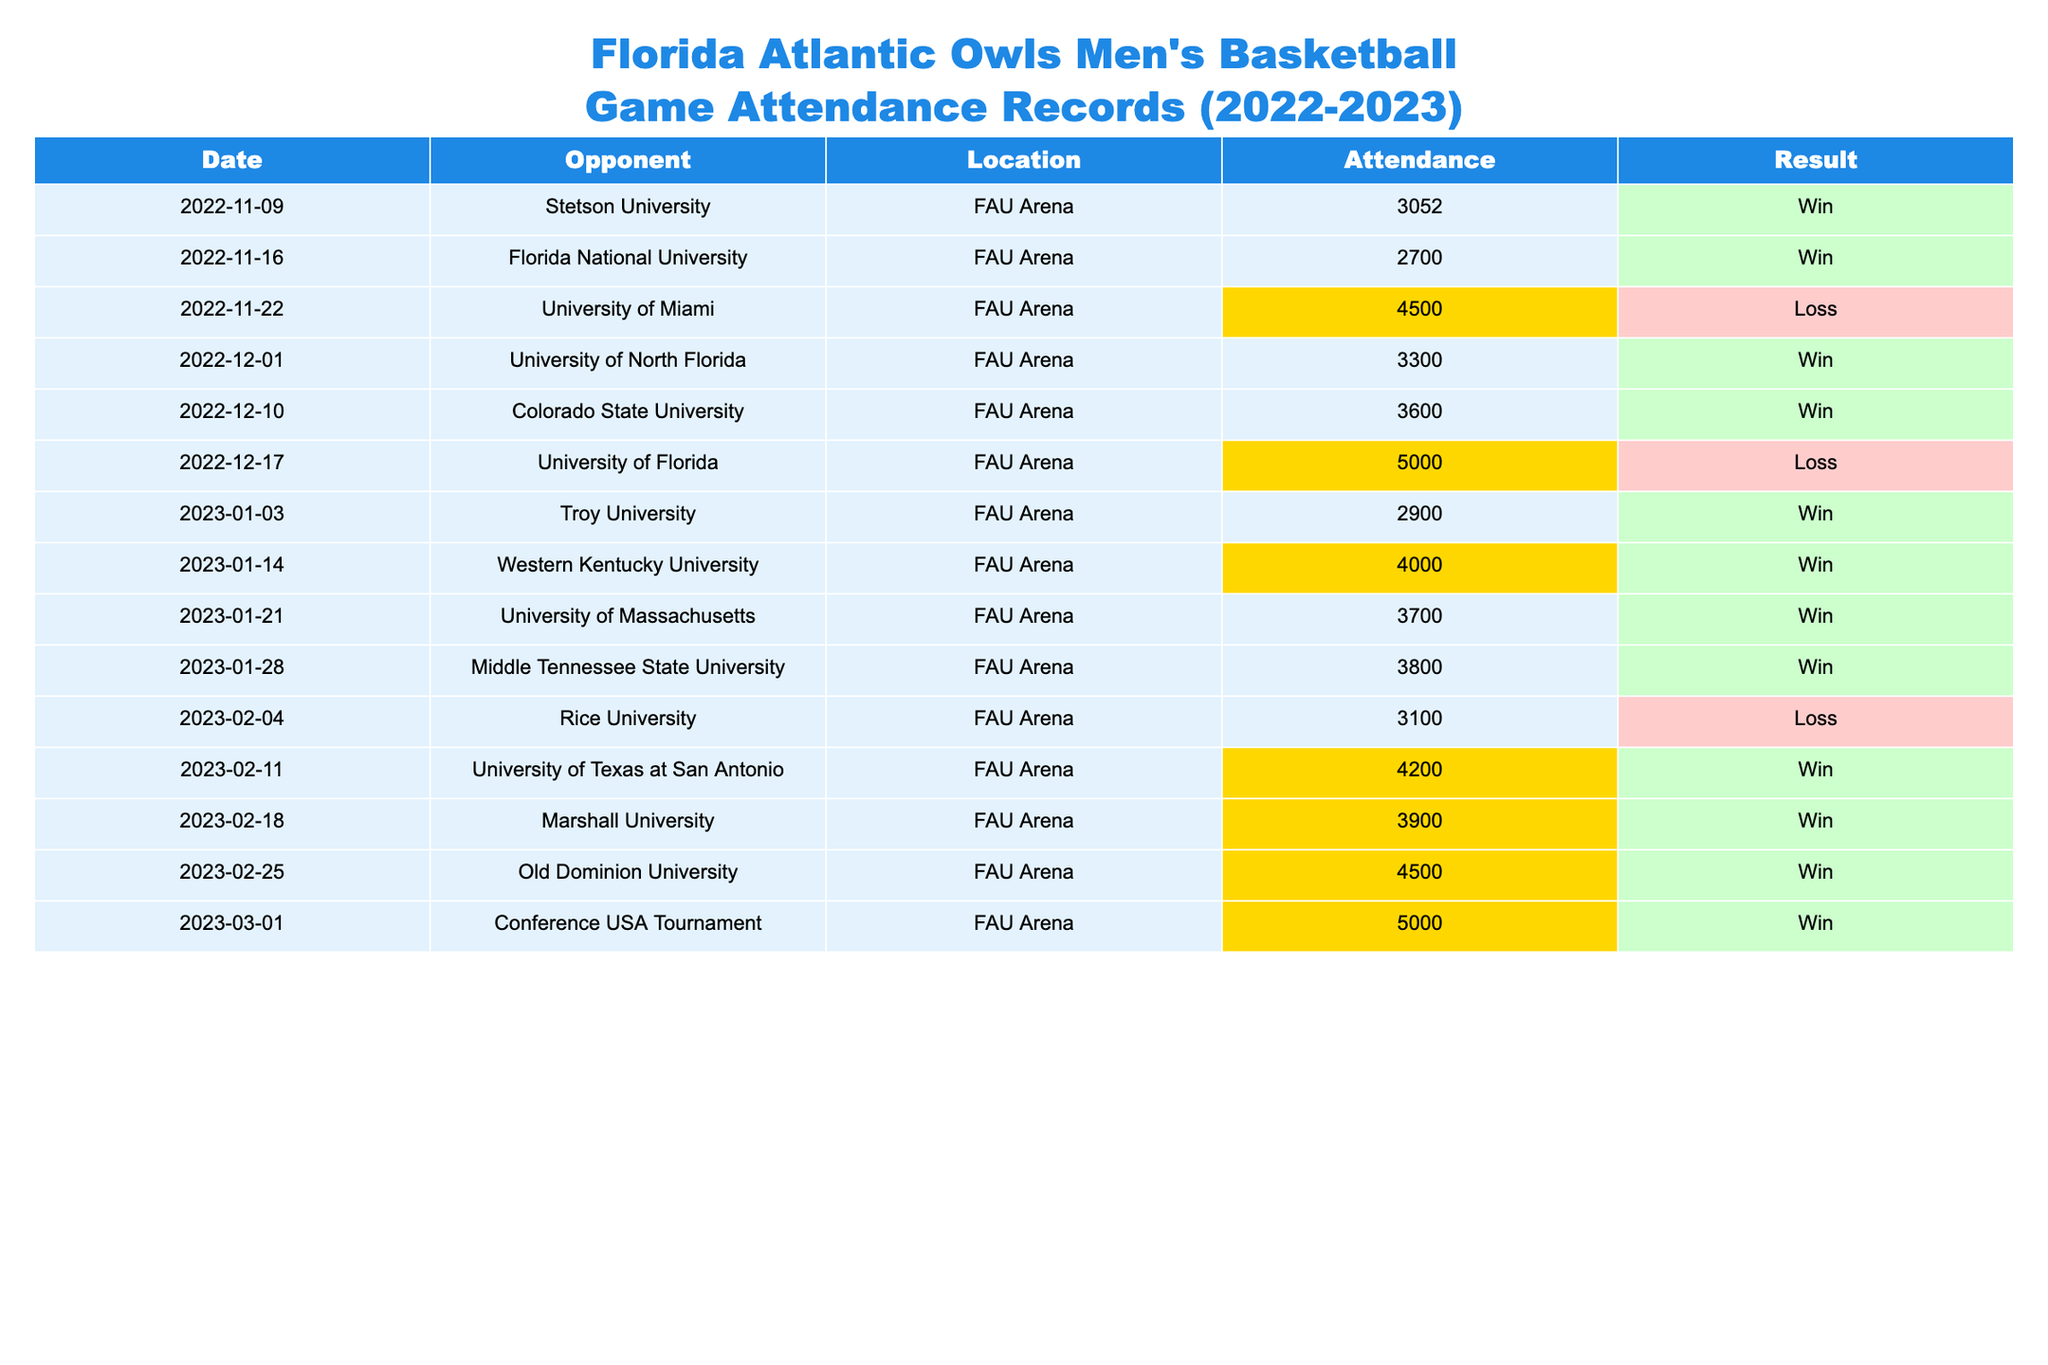What was the highest attendance at a game during the season? The table shows the attendance for each game. Looking through the values, the highest attendance is 5000, which occurred during the games against the University of Florida and the Conference USA Tournament.
Answer: 5000 Which game had the lowest attendance? The table lists the attendances for all games and identifies the lowest value. The lowest attendance was 2700 for the game against Florida National University.
Answer: 2700 Was the team more likely to win or lose games with above-average attendance? To determine this, we first find the average attendance, which is approximately 3850. Then, we check wins and losses for games with attendance above this average. There are more wins (6 wins) than losses (2 losses) among the games with above-average attendance.
Answer: More likely to win What is the average game attendance for the season? To find the average, sum all attendance values: 3052 + 2700 + 4500 + 3300 + 3600 + 5000 + 2900 + 4000 + 3700 + 3800 + 3100 + 4200 + 3900 + 4500 + 5000 = 50000. There are 15 games, so the average attendance is 50000 / 15 ≈ 3333.33.
Answer: Approximately 3333 How many games did the Florida Atlantic Owls win with an attendance above 4000? Checking the table, the games with attendance above 4000 are those against the University of Miami, University of Florida, University of Texas at San Antonio, Old Dominion University, and the Conference USA Tournament. Among them, the team won 4 games; they only lost against the University of Florida.
Answer: 4 How many games resulted in a loss, and what were their attendances? The table indicates that there are three losses: one against the University of Miami with 4500 attendees, one against the University of Florida with 5000 attendees, and one against Rice University with 3100 attendees.
Answer: 3 losses: 4500, 5000, 3100 Did the team ever have a game with an attendance of exactly 4000? Reviewing the table, there is one game against Western Kentucky University where the attendance was exactly 4000.
Answer: Yes What is the difference in attendance between the game with the highest and the game with the lowest attendance? The highest attendance is 5000 (University of Florida or Conference USA Tournament), and the lowest is 2700 (Florida National University). The difference in attendance is calculated as 5000 - 2700 = 2300.
Answer: 2300 